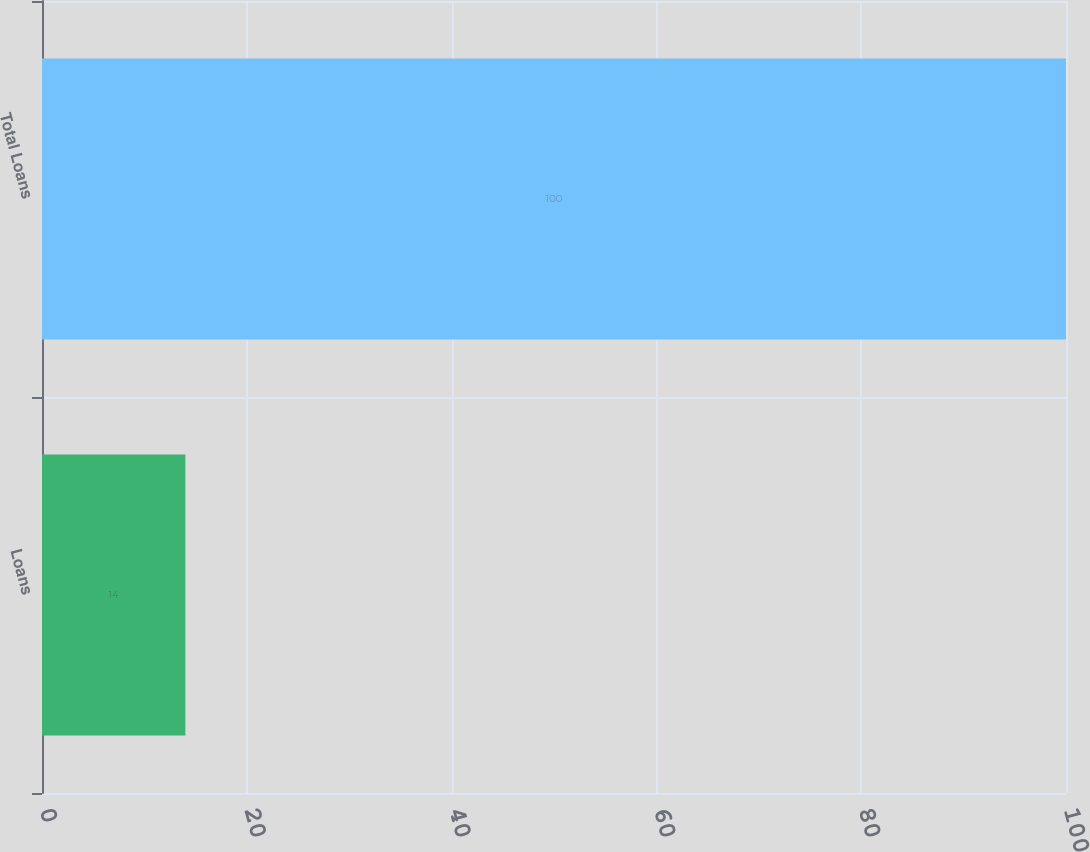<chart> <loc_0><loc_0><loc_500><loc_500><bar_chart><fcel>Loans<fcel>Total Loans<nl><fcel>14<fcel>100<nl></chart> 